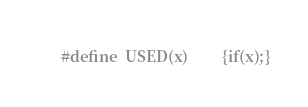Convert code to text. <code><loc_0><loc_0><loc_500><loc_500><_C_>#define	USED(x)			{if(x);}
</code> 